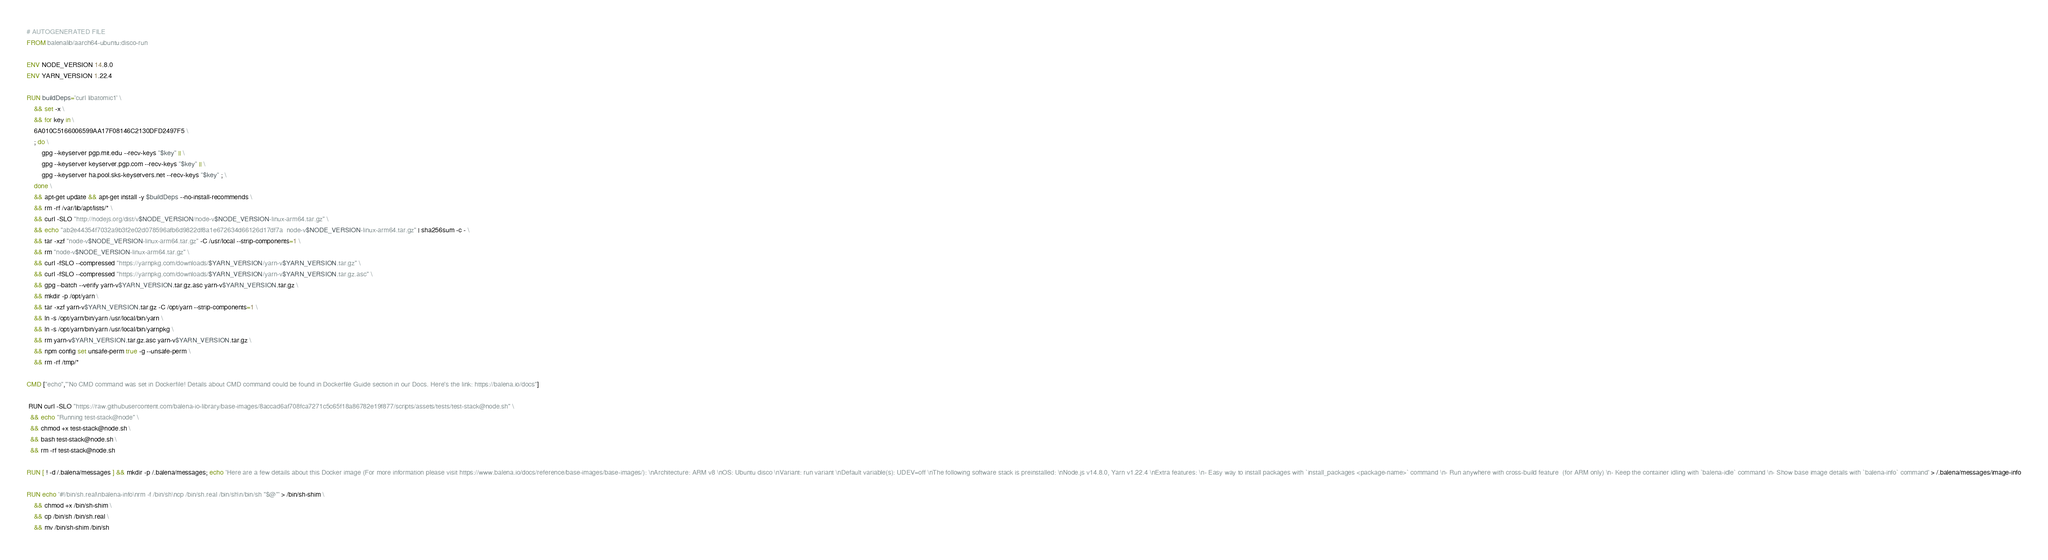<code> <loc_0><loc_0><loc_500><loc_500><_Dockerfile_># AUTOGENERATED FILE
FROM balenalib/aarch64-ubuntu:disco-run

ENV NODE_VERSION 14.8.0
ENV YARN_VERSION 1.22.4

RUN buildDeps='curl libatomic1' \
	&& set -x \
	&& for key in \
	6A010C5166006599AA17F08146C2130DFD2497F5 \
	; do \
		gpg --keyserver pgp.mit.edu --recv-keys "$key" || \
		gpg --keyserver keyserver.pgp.com --recv-keys "$key" || \
		gpg --keyserver ha.pool.sks-keyservers.net --recv-keys "$key" ; \
	done \
	&& apt-get update && apt-get install -y $buildDeps --no-install-recommends \
	&& rm -rf /var/lib/apt/lists/* \
	&& curl -SLO "http://nodejs.org/dist/v$NODE_VERSION/node-v$NODE_VERSION-linux-arm64.tar.gz" \
	&& echo "ab2e44354f7032a9b3f2e02d078596afb6d9822df8a1e672634d66126d17df7a  node-v$NODE_VERSION-linux-arm64.tar.gz" | sha256sum -c - \
	&& tar -xzf "node-v$NODE_VERSION-linux-arm64.tar.gz" -C /usr/local --strip-components=1 \
	&& rm "node-v$NODE_VERSION-linux-arm64.tar.gz" \
	&& curl -fSLO --compressed "https://yarnpkg.com/downloads/$YARN_VERSION/yarn-v$YARN_VERSION.tar.gz" \
	&& curl -fSLO --compressed "https://yarnpkg.com/downloads/$YARN_VERSION/yarn-v$YARN_VERSION.tar.gz.asc" \
	&& gpg --batch --verify yarn-v$YARN_VERSION.tar.gz.asc yarn-v$YARN_VERSION.tar.gz \
	&& mkdir -p /opt/yarn \
	&& tar -xzf yarn-v$YARN_VERSION.tar.gz -C /opt/yarn --strip-components=1 \
	&& ln -s /opt/yarn/bin/yarn /usr/local/bin/yarn \
	&& ln -s /opt/yarn/bin/yarn /usr/local/bin/yarnpkg \
	&& rm yarn-v$YARN_VERSION.tar.gz.asc yarn-v$YARN_VERSION.tar.gz \
	&& npm config set unsafe-perm true -g --unsafe-perm \
	&& rm -rf /tmp/*

CMD ["echo","'No CMD command was set in Dockerfile! Details about CMD command could be found in Dockerfile Guide section in our Docs. Here's the link: https://balena.io/docs"]

 RUN curl -SLO "https://raw.githubusercontent.com/balena-io-library/base-images/8accad6af708fca7271c5c65f18a86782e19f877/scripts/assets/tests/test-stack@node.sh" \
  && echo "Running test-stack@node" \
  && chmod +x test-stack@node.sh \
  && bash test-stack@node.sh \
  && rm -rf test-stack@node.sh 

RUN [ ! -d /.balena/messages ] && mkdir -p /.balena/messages; echo 'Here are a few details about this Docker image (For more information please visit https://www.balena.io/docs/reference/base-images/base-images/): \nArchitecture: ARM v8 \nOS: Ubuntu disco \nVariant: run variant \nDefault variable(s): UDEV=off \nThe following software stack is preinstalled: \nNode.js v14.8.0, Yarn v1.22.4 \nExtra features: \n- Easy way to install packages with `install_packages <package-name>` command \n- Run anywhere with cross-build feature  (for ARM only) \n- Keep the container idling with `balena-idle` command \n- Show base image details with `balena-info` command' > /.balena/messages/image-info

RUN echo '#!/bin/sh.real\nbalena-info\nrm -f /bin/sh\ncp /bin/sh.real /bin/sh\n/bin/sh "$@"' > /bin/sh-shim \
	&& chmod +x /bin/sh-shim \
	&& cp /bin/sh /bin/sh.real \
	&& mv /bin/sh-shim /bin/sh</code> 